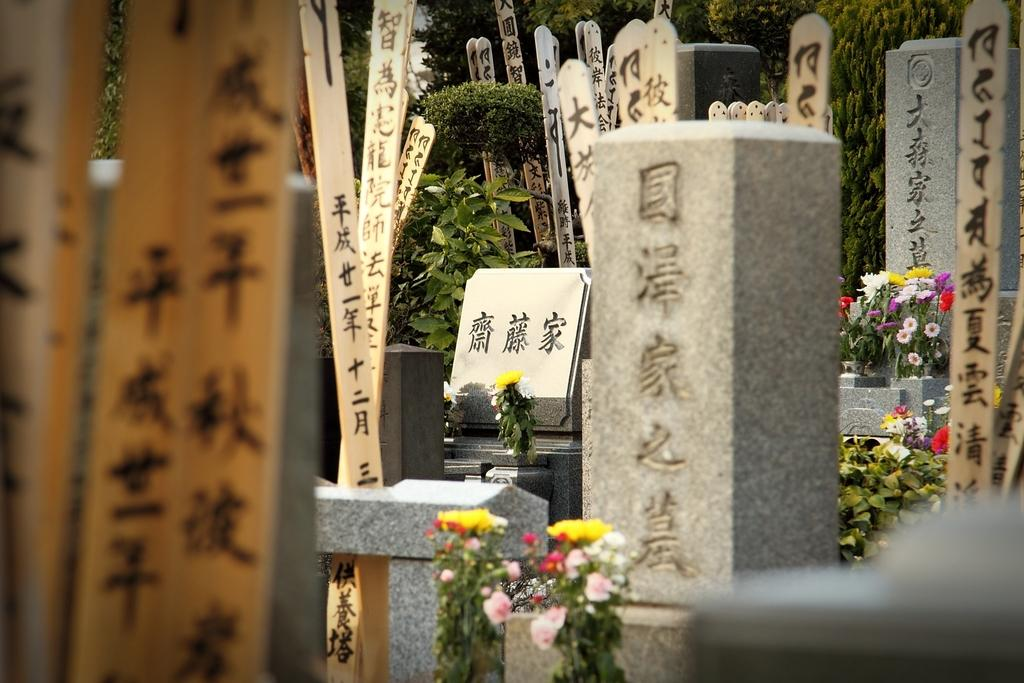What type of location is depicted in the image? The image contains cemeteries. What can be seen in the image besides the cemeteries? There are flowers of multiple colors and trees in the background of the image. What is the color of the trees in the image? The trees are green. What is visible in the background of the image? The sky is visible in the background of the image. What is the color of the sky in the image? The sky is white. Where is the bucket located in the image? There is no bucket present in the image. What type of church can be seen in the image? There is no church present in the image. 